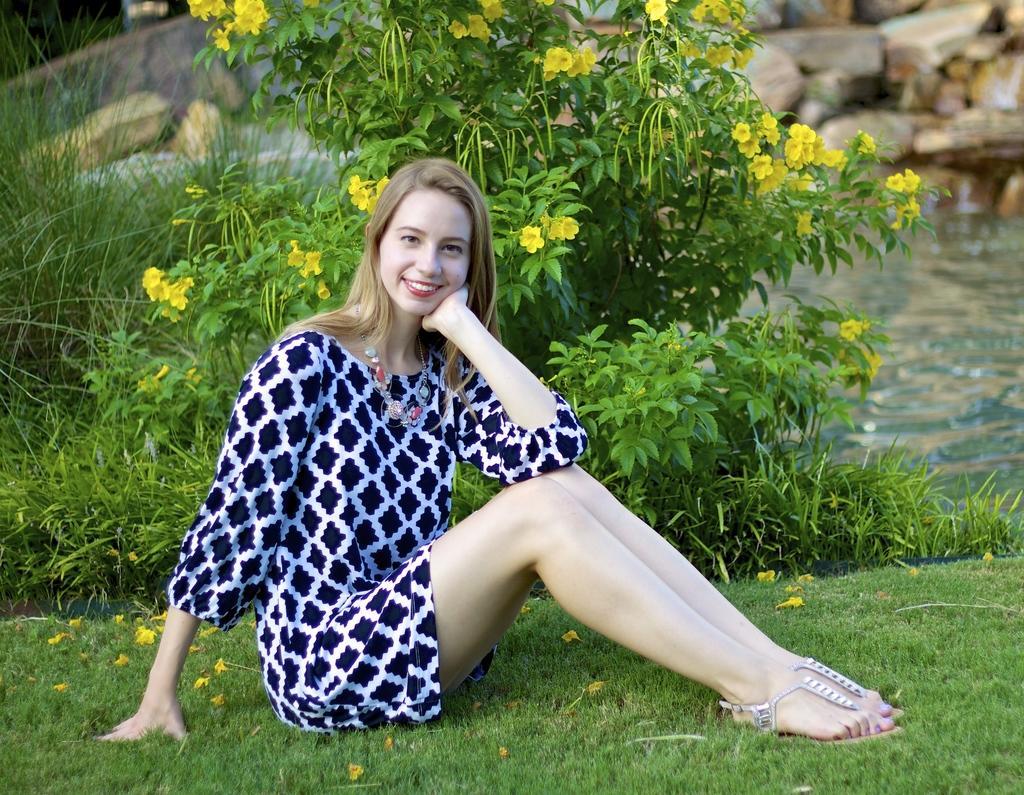How would you summarize this image in a sentence or two? In this picture there is a woman sitting and smiling. At the back there are rocks and there are plants and there are yellow color flowers on the plant. At the bottom there is water and there is grass. 